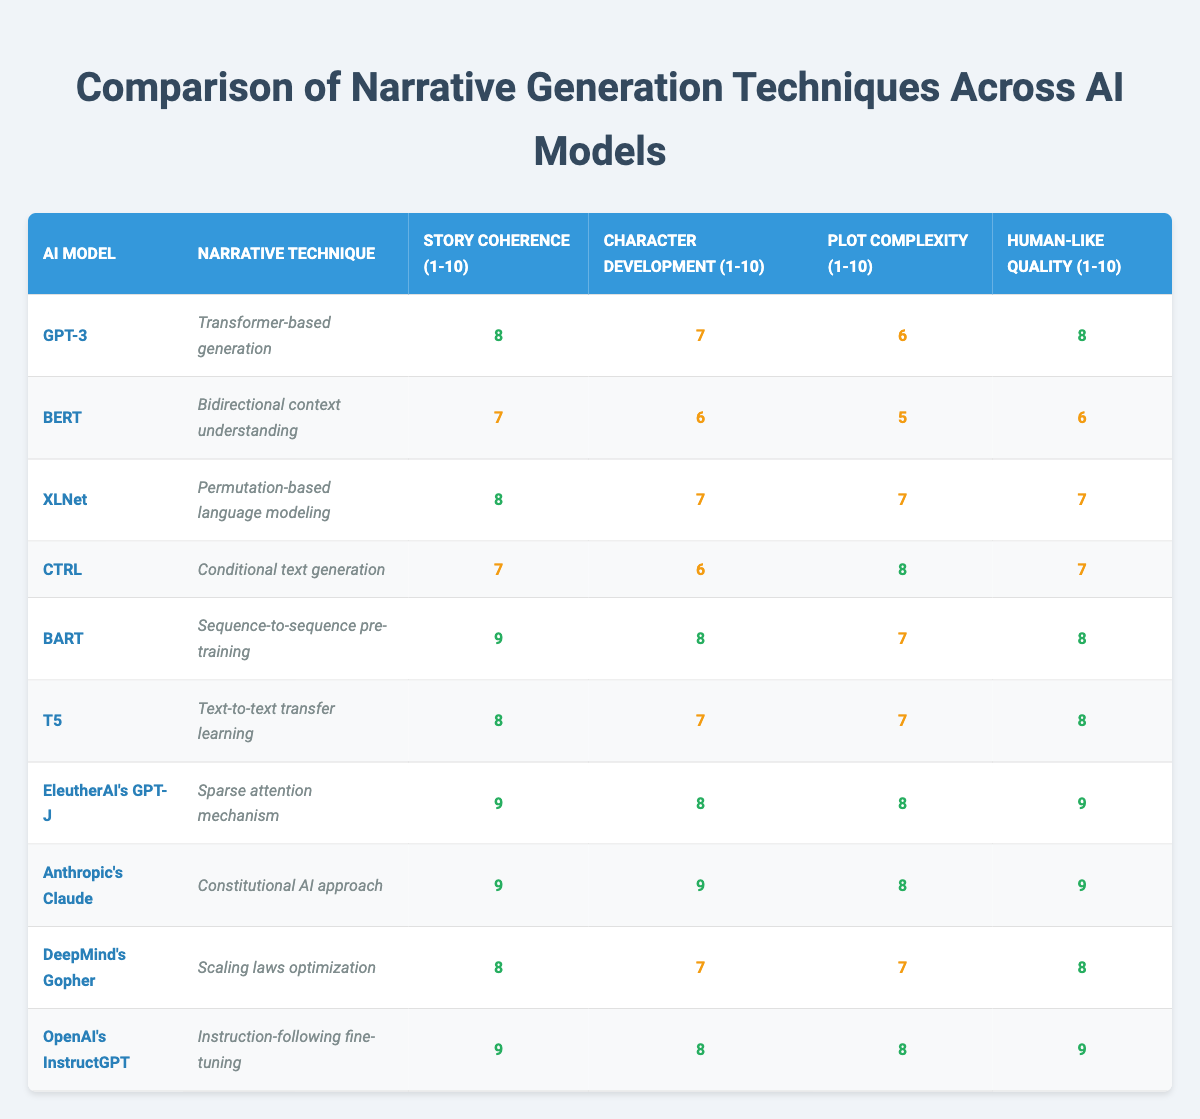What is the story coherence score for BART? By looking at the row corresponding to BART, the story coherence score is listed as 9.
Answer: 9 What is the character development score for the AI model with the highest plot complexity? The AI model with the highest plot complexity is CTRL, which has a score of 8 for character development.
Answer: 6 Which AI model utilizes a conditional text generation technique? The AI model that uses a conditional text generation technique is CTRL, as indicated in its narrative technique description.
Answer: CTRL What are the average human-like quality scores for the models that have a rating of 9 in story coherence? The models with a story coherence rating of 9 are BART, EleutherAI's GPT-J, Anthropic's Claude, and OpenAI's InstructGPT. Their human-like quality scores are 8, 9, 9, and 9 respectively. Adding them gives a total of 35, and dividing by 4 (the number of models) results in an average of 8.75.
Answer: 8.75 Is the character development score for GPT-3 higher than that of BERT? GPT-3 has a character development score of 7 while BERT has a score of 6, therefore, GPT-3’s score is higher than BERT's.
Answer: Yes Which narrative technique has the highest average plot complexity score across all models? The plot complexity scores for each model are 6 (GPT-3), 5 (BERT), 7 (XLNet), 8 (CTRL), 7 (BART), 7 (T5), 8 (GPT-J), 8 (Claude), 7 (Gopher), and 8 (InstructGPT). Adding these gives a total of 71 for 10 data points. The average plot complexity score is 71/10, which equals 7.1. While the specific narrative technique with the highest score is not computed, the highest individual plot complexity score is 8 (CTRL, Claude, InstructGPT, GPT-J).
Answer: 8 Does DeepMind's Gopher have a story coherence score lower than 8? Gopher has a story coherence score of 8, therefore it does not have a lower score.
Answer: No Which AI model demonstrates the best overall performance based on all categories? To determine the best overall performance, we can sum the scores across all categories for each model. For Anthropic's Claude, the total score is 9 (story coherence) + 9 + 8 + 9 = 35. Other models can be compared similarly, such as BART with a total of 32. After comparing sums, it's clear that Claude scores the highest overall with a total of 35.
Answer: Anthropic's Claude 